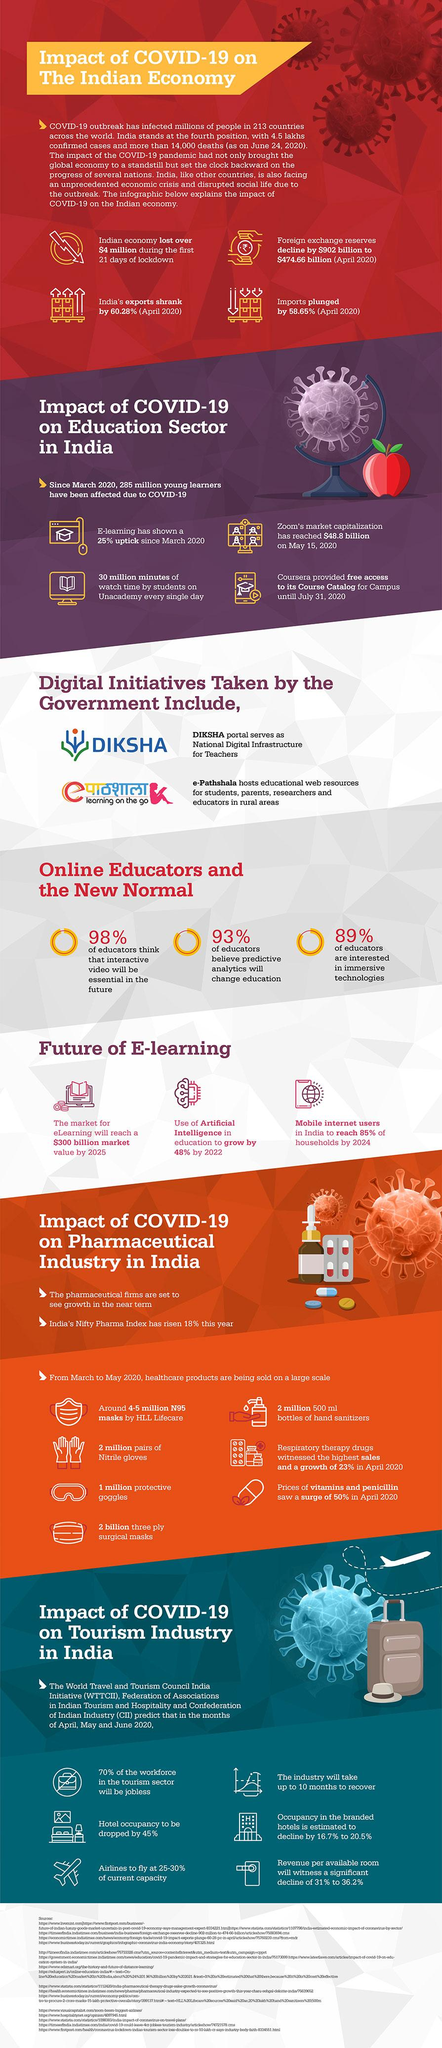Specify some key components in this picture. The tourism industry is expected to recoup its losses within 10 months. We produced 2 million half liter bottles of sanitizers. Indian exports have decreased by 60.28% compared to the previous year. According to the survey conducted, a staggering 98% of educators believed that interactive videos will be a necessity in the future of education. Zoom, a video conferencing company, has reached a market capitalization of $45 billion. 